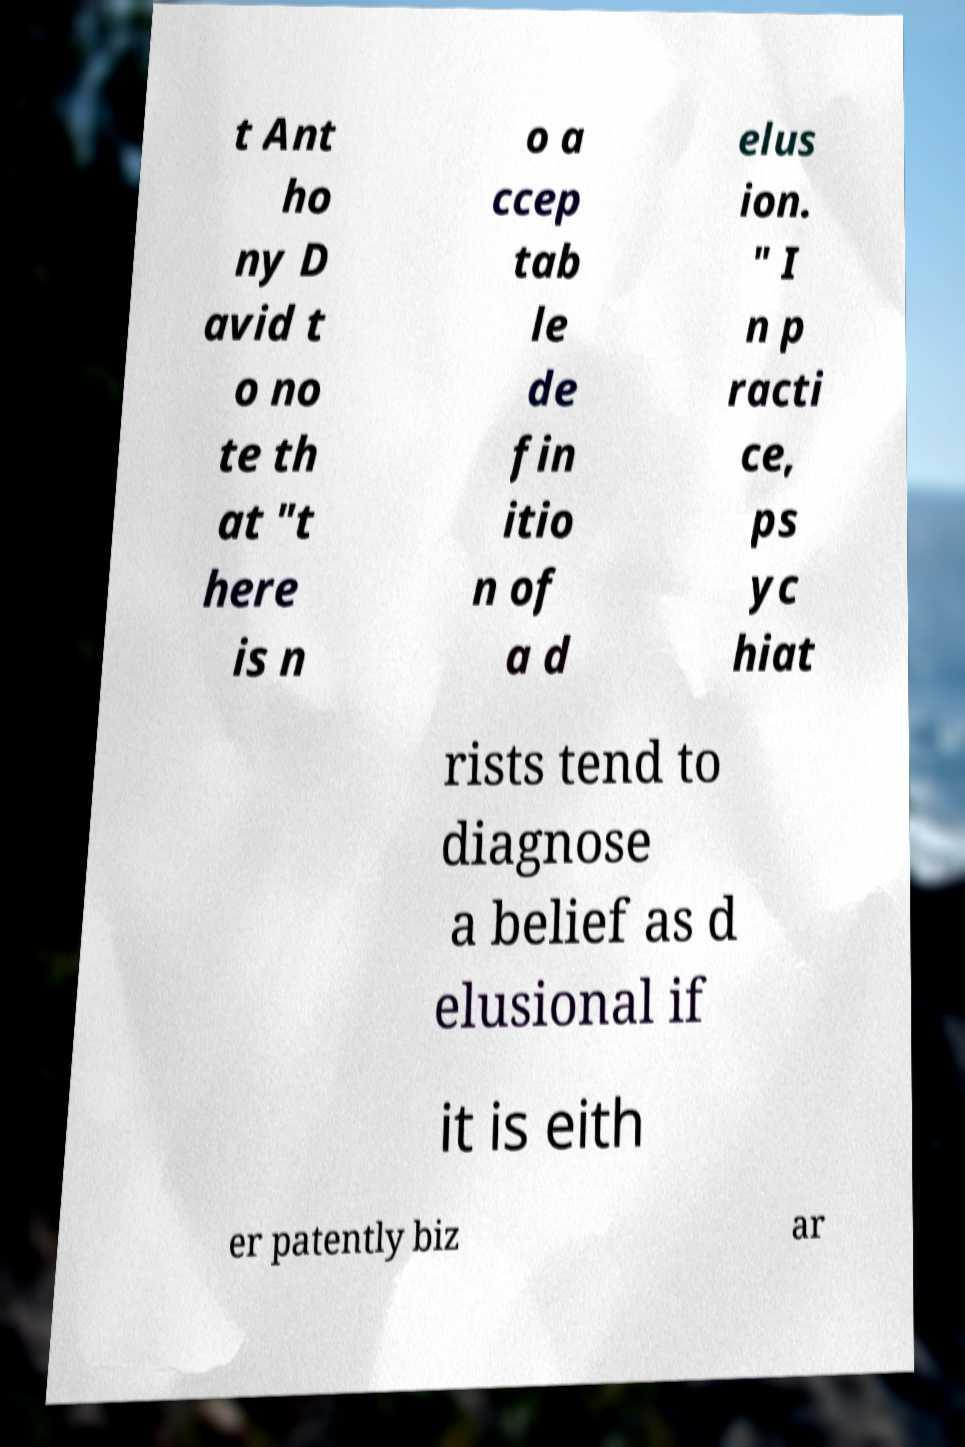For documentation purposes, I need the text within this image transcribed. Could you provide that? t Ant ho ny D avid t o no te th at "t here is n o a ccep tab le de fin itio n of a d elus ion. " I n p racti ce, ps yc hiat rists tend to diagnose a belief as d elusional if it is eith er patently biz ar 